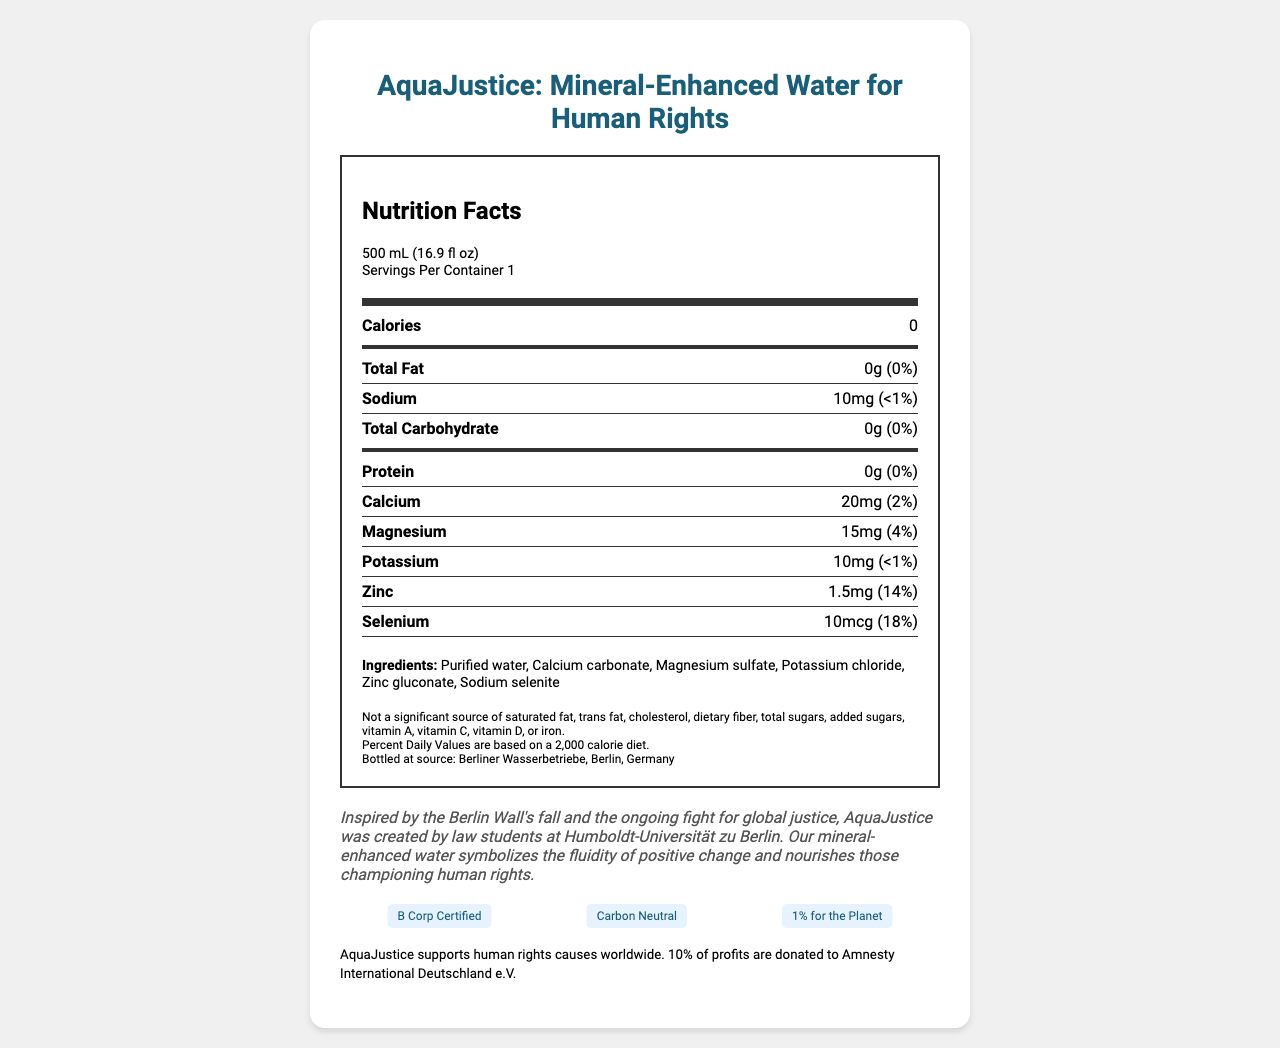what is the name of the product? The product name is clearly listed at the top of the document.
Answer: AquaJustice: Mineral-Enhanced Water for Human Rights what is the serving size of AquaJustice water? The serving size is mentioned under the Nutrition Facts section as "500 mL (16.9 fl oz)".
Answer: 500 mL (16.9 fl oz) how many servings are in the container? Under the Nutrition Facts section, it states "Servings Per Container 1".
Answer: 1 how many calories are in one serving? In the Nutrition Facts section, it mentions that each serving has 0 calories.
Answer: 0 calories what minerals are present in AquaJustice water? The minerals listed in the nutrient section are Calcium, Magnesium, Potassium, Zinc, and Selenium.
Answer: Calcium, Magnesium, Potassium, Zinc, Selenium what is the percent daily value (%DV) of Zinc in one serving? The nutrient section mentions that the %DV for Zinc is 14%.
Answer: 14% what is the brand story of AquaJustice? The brand story is provided at the bottom of the document in the "brand story" section.
Answer: Inspired by the Berlin Wall's fall and the ongoing fight for global justice, AquaJustice was created by law students at Humboldt-Universität zu Berlin... what percentage of profits is donated to Amnesty International Deutschland e.V.? The legal disclaimer at the bottom of the document states, "10% of profits are donated to Amnesty International Deutschland e.V."
Answer: 10% which of the following is not an ingredient in AquaJustice water? A. Zinc gluconate B. Potassium chloride C. Magnesium sulfate D. Sodium benzoate Sodium benzoate is not listed among the ingredients.
Answer: D where is AquaJustice water bottled? A. Berliner Wasserbetriebe, Berlin, Germany B. Hamburg Wasserwerke, Hamburg, Germany C. Münchener Stadtwerke, Munich, Germany D. Frankfurter Wasserbetriebe, Frankfurt, Germany The document states that AquaJustice water is bottled at Berliner Wasserbetriebe, Berlin, Germany.
Answer: A is AquaJustice water a significant source of dietary fiber? The additional information section states that it is not a significant source of dietary fiber.
Answer: No of the antibiotics included in AquaJustice, which has the highest daily value percentage? Calcium, Zinc, Magnesium, Selenium According to the nutrient section, Selenium has the highest daily value percentage at 18%.
Answer: Selenium summarize the key points of the AquaJustice Nutrition Facts Label. This summary includes the main aspects presented in the document, including the product's purpose, nutritional content, donation details, inspiration, and certifications.
Answer: AquaJustice: Mineral-Enhanced Water for Human Rights is a 500 mL bottled water product with 0 calories per serving. It contains various minerals such as Calcium (2% DV), Magnesium (4% DV), Potassium (<1% DV), Zinc (14% DV), and Selenium (18% DV). Ingredients include purified water, calcium carbonate, and more. Despite a lack of fats, carbohydrates, protein, and dietary fiber, it is fortified with essential minerals. The product supports human rights causes, donating 10% of profits to Amnesty International Deutschland. It is B Corp Certified, Carbon Neutral, and part of 1% for the Planet. The brand was inspired by the fall of the Berlin Wall and ongoing global justice fights, created by law students at Humboldt-Universität zu Berlin. does AquaJustice have any certifications? The document lists several certifications for AquaJustice, such as B Corp Certified, Carbon Neutral, and 1% for the Planet.
Answer: Yes how much sodium is in one serving of AquaJustice water? The Nutrition Facts section indicates that there are 10mg of Sodium per serving.
Answer: 10mg what is the purpose of AquaJustice supporting human rights causes? The document mentions that 10% of profits are donated to Amnesty International Deutschland e.V., but does not elaborate on the underlying purpose or specific causes supported.
Answer: Not enough information 